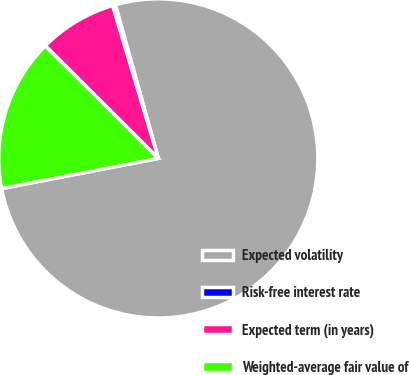Convert chart to OTSL. <chart><loc_0><loc_0><loc_500><loc_500><pie_chart><fcel>Expected volatility<fcel>Risk-free interest rate<fcel>Expected term (in years)<fcel>Weighted-average fair value of<nl><fcel>76.31%<fcel>0.29%<fcel>7.9%<fcel>15.5%<nl></chart> 